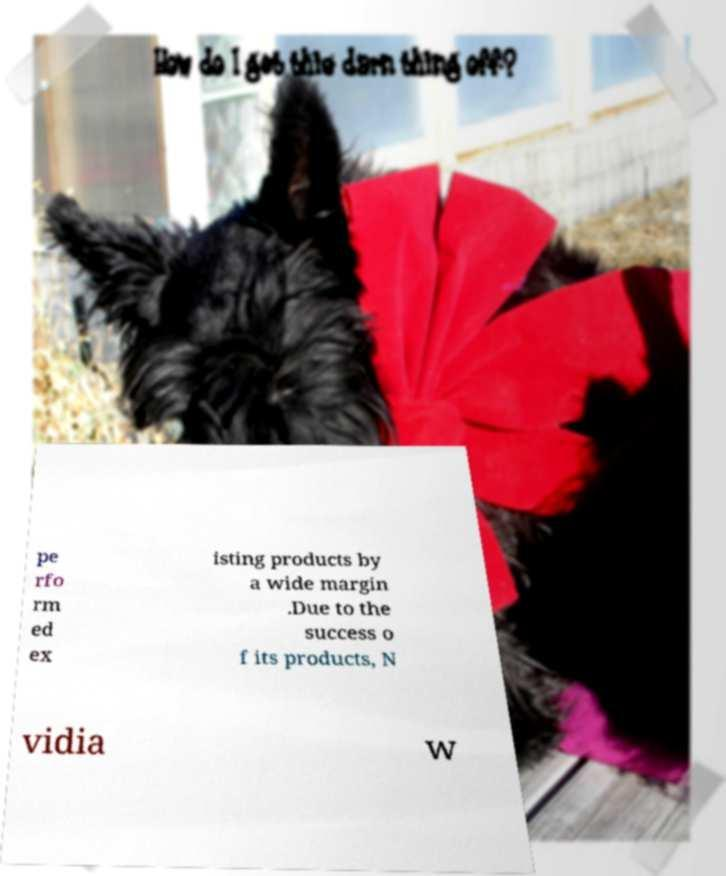Please identify and transcribe the text found in this image. pe rfo rm ed ex isting products by a wide margin .Due to the success o f its products, N vidia w 